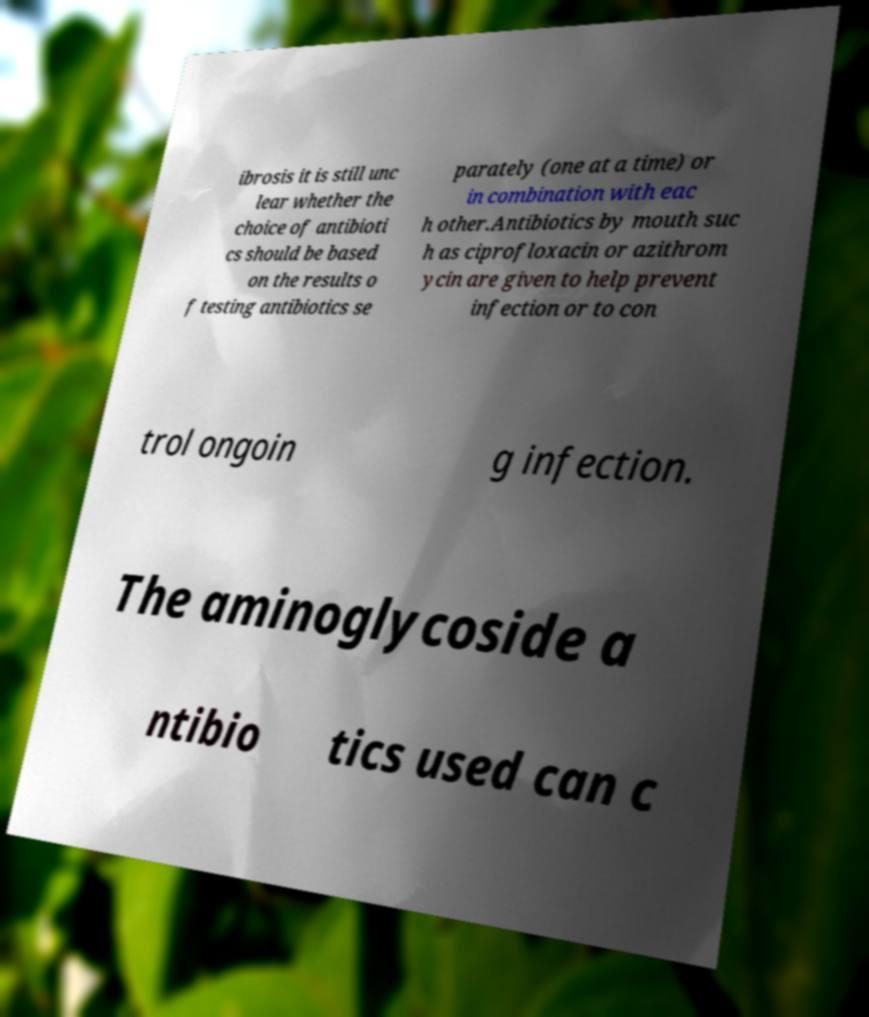Please read and relay the text visible in this image. What does it say? ibrosis it is still unc lear whether the choice of antibioti cs should be based on the results o f testing antibiotics se parately (one at a time) or in combination with eac h other.Antibiotics by mouth suc h as ciprofloxacin or azithrom ycin are given to help prevent infection or to con trol ongoin g infection. The aminoglycoside a ntibio tics used can c 